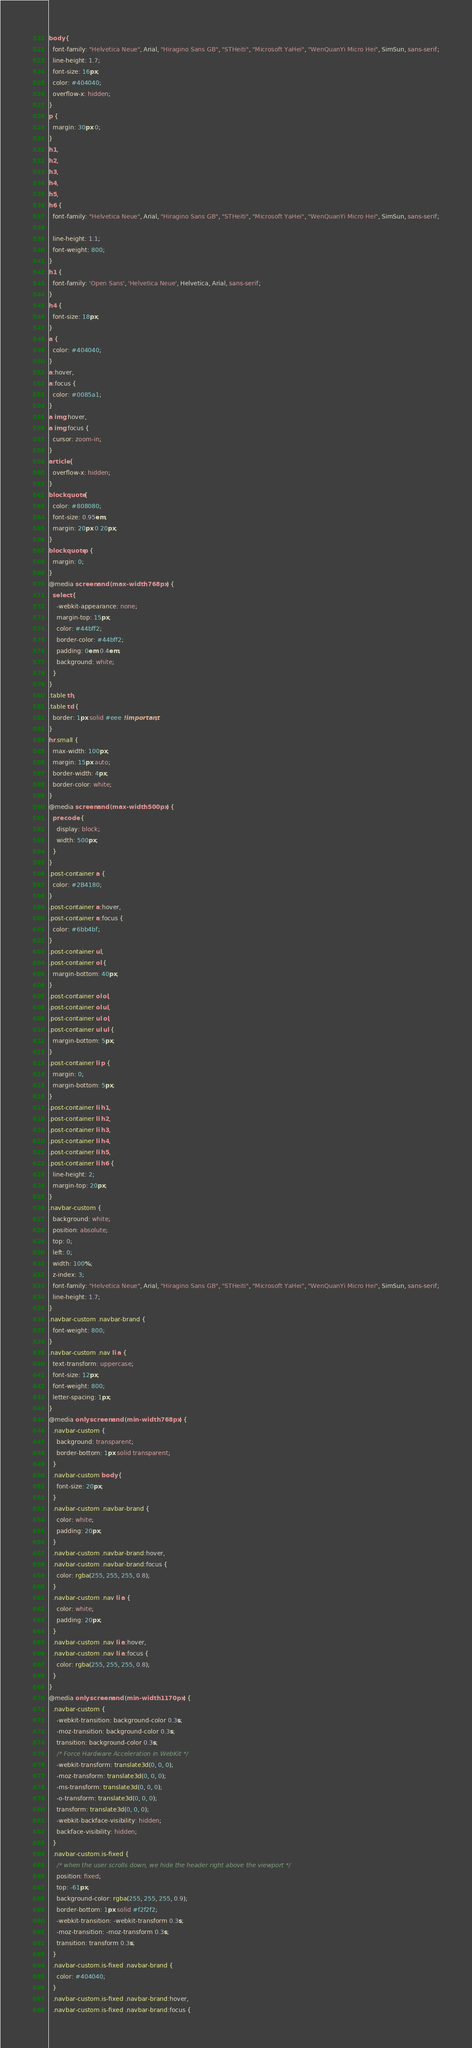<code> <loc_0><loc_0><loc_500><loc_500><_CSS_>body {
  font-family: "Helvetica Neue", Arial, "Hiragino Sans GB", "STHeiti", "Microsoft YaHei", "WenQuanYi Micro Hei", SimSun, sans-serif;
  line-height: 1.7;
  font-size: 16px;
  color: #404040;
  overflow-x: hidden;
}
p {
  margin: 30px 0;
}
h1,
h2,
h3,
h4,
h5,
h6 {
  font-family: "Helvetica Neue", Arial, "Hiragino Sans GB", "STHeiti", "Microsoft YaHei", "WenQuanYi Micro Hei", SimSun, sans-serif;

  line-height: 1.1;
  font-weight: 800;
}
h1 {
  font-family: 'Open Sans', 'Helvetica Neue', Helvetica, Arial, sans-serif;
}
h4 {
  font-size: 18px;
}
a {
  color: #404040;
}
a:hover,
a:focus {
  color: #0085a1;
}
a img:hover,
a img:focus {
  cursor: zoom-in;
}
article {
  overflow-x: hidden;
}
blockquote {
  color: #808080;
  font-size: 0.95em;
  margin: 20px 0 20px;
}
blockquote p {
  margin: 0;
}
@media screen and (max-width: 768px) {
  select {
    -webkit-appearance: none;
    margin-top: 15px;
    color: #44bff2;
    border-color: #44bff2;
    padding: 0em 0.4em;
    background: white;
  }
}
.table th,
.table td {
  border: 1px solid #eee !important;
}
hr.small {
  max-width: 100px;
  margin: 15px auto;
  border-width: 4px;
  border-color: white;
}
@media screen and (max-width: 500px) {
  pre code {
    display: block;
    width: 500px;
  }
}
.post-container a {
  color: #2B4180;
}
.post-container a:hover,
.post-container a:focus {
  color: #6bb4bf;
}
.post-container ul,
.post-container ol {
  margin-bottom: 40px;
}
.post-container ol ol,
.post-container ol ul,
.post-container ul ol,
.post-container ul ul {
  margin-bottom: 5px;
}
.post-container li p {
  margin: 0;
  margin-bottom: 5px;
}
.post-container li h1,
.post-container li h2,
.post-container li h3,
.post-container li h4,
.post-container li h5,
.post-container li h6 {
  line-height: 2;
  margin-top: 20px;
}
.navbar-custom {
  background: white;
  position: absolute;
  top: 0;
  left: 0;
  width: 100%;
  z-index: 3;
  font-family: "Helvetica Neue", Arial, "Hiragino Sans GB", "STHeiti", "Microsoft YaHei", "WenQuanYi Micro Hei", SimSun, sans-serif;
  line-height: 1.7;
}
.navbar-custom .navbar-brand {
  font-weight: 800;
}
.navbar-custom .nav li a {
  text-transform: uppercase;
  font-size: 12px;
  font-weight: 800;
  letter-spacing: 1px;
}
@media only screen and (min-width: 768px) {
  .navbar-custom {
    background: transparent;
    border-bottom: 1px solid transparent;
  }
  .navbar-custom body {
    font-size: 20px;
  }
  .navbar-custom .navbar-brand {
    color: white;
    padding: 20px;
  }
  .navbar-custom .navbar-brand:hover,
  .navbar-custom .navbar-brand:focus {
    color: rgba(255, 255, 255, 0.8);
  }
  .navbar-custom .nav li a {
    color: white;
    padding: 20px;
  }
  .navbar-custom .nav li a:hover,
  .navbar-custom .nav li a:focus {
    color: rgba(255, 255, 255, 0.8);
  }
}
@media only screen and (min-width: 1170px) {
  .navbar-custom {
    -webkit-transition: background-color 0.3s;
    -moz-transition: background-color 0.3s;
    transition: background-color 0.3s;
    /* Force Hardware Acceleration in WebKit */
    -webkit-transform: translate3d(0, 0, 0);
    -moz-transform: translate3d(0, 0, 0);
    -ms-transform: translate3d(0, 0, 0);
    -o-transform: translate3d(0, 0, 0);
    transform: translate3d(0, 0, 0);
    -webkit-backface-visibility: hidden;
    backface-visibility: hidden;
  }
  .navbar-custom.is-fixed {
    /* when the user scrolls down, we hide the header right above the viewport */
    position: fixed;
    top: -61px;
    background-color: rgba(255, 255, 255, 0.9);
    border-bottom: 1px solid #f2f2f2;
    -webkit-transition: -webkit-transform 0.3s;
    -moz-transition: -moz-transform 0.3s;
    transition: transform 0.3s;
  }
  .navbar-custom.is-fixed .navbar-brand {
    color: #404040;
  }
  .navbar-custom.is-fixed .navbar-brand:hover,
  .navbar-custom.is-fixed .navbar-brand:focus {</code> 